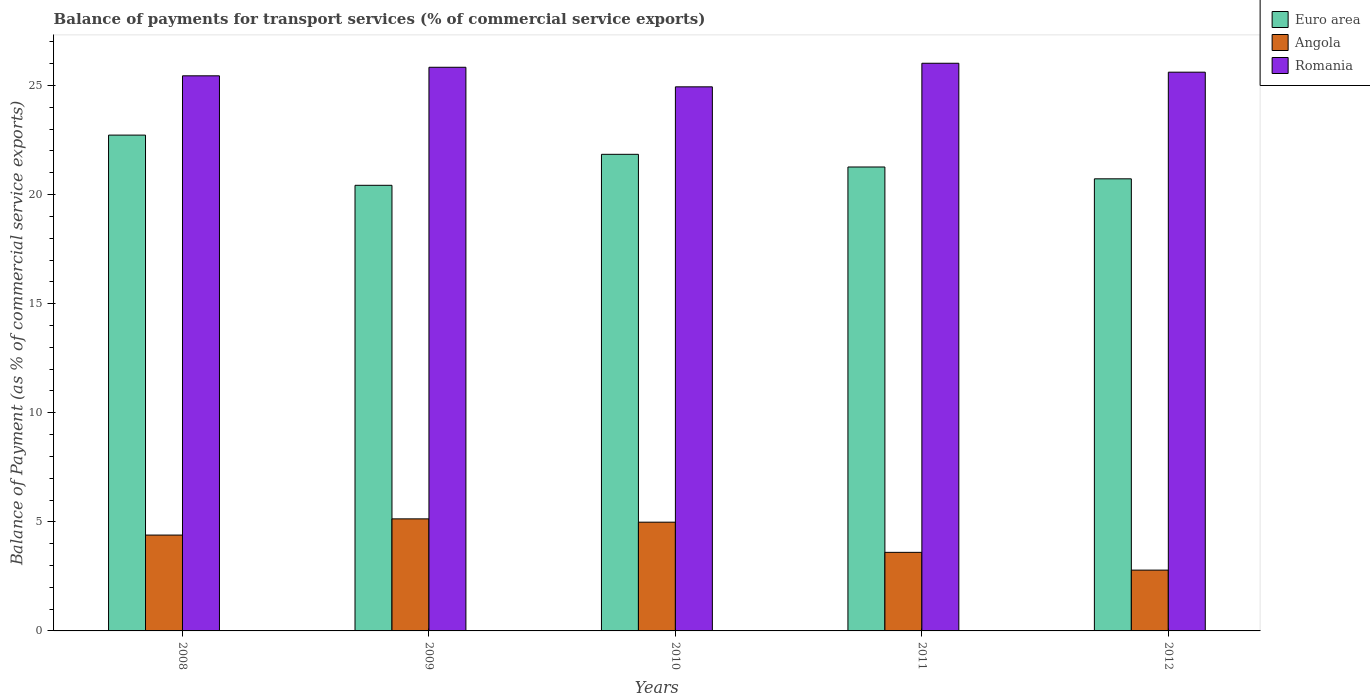Are the number of bars per tick equal to the number of legend labels?
Your answer should be very brief. Yes. Are the number of bars on each tick of the X-axis equal?
Provide a short and direct response. Yes. How many bars are there on the 3rd tick from the left?
Provide a succinct answer. 3. How many bars are there on the 5th tick from the right?
Keep it short and to the point. 3. What is the label of the 1st group of bars from the left?
Provide a short and direct response. 2008. In how many cases, is the number of bars for a given year not equal to the number of legend labels?
Provide a short and direct response. 0. What is the balance of payments for transport services in Angola in 2010?
Your response must be concise. 4.98. Across all years, what is the maximum balance of payments for transport services in Euro area?
Your answer should be compact. 22.73. Across all years, what is the minimum balance of payments for transport services in Euro area?
Your response must be concise. 20.42. In which year was the balance of payments for transport services in Romania minimum?
Your answer should be very brief. 2010. What is the total balance of payments for transport services in Romania in the graph?
Your answer should be compact. 127.84. What is the difference between the balance of payments for transport services in Angola in 2008 and that in 2012?
Keep it short and to the point. 1.61. What is the difference between the balance of payments for transport services in Euro area in 2009 and the balance of payments for transport services in Angola in 2012?
Offer a very short reply. 17.64. What is the average balance of payments for transport services in Euro area per year?
Your answer should be compact. 21.4. In the year 2012, what is the difference between the balance of payments for transport services in Romania and balance of payments for transport services in Angola?
Give a very brief answer. 22.82. In how many years, is the balance of payments for transport services in Angola greater than 18 %?
Your answer should be very brief. 0. What is the ratio of the balance of payments for transport services in Romania in 2009 to that in 2011?
Provide a succinct answer. 0.99. Is the difference between the balance of payments for transport services in Romania in 2009 and 2012 greater than the difference between the balance of payments for transport services in Angola in 2009 and 2012?
Your answer should be compact. No. What is the difference between the highest and the second highest balance of payments for transport services in Angola?
Provide a short and direct response. 0.15. What is the difference between the highest and the lowest balance of payments for transport services in Romania?
Your answer should be compact. 1.08. In how many years, is the balance of payments for transport services in Angola greater than the average balance of payments for transport services in Angola taken over all years?
Offer a terse response. 3. Is the sum of the balance of payments for transport services in Angola in 2008 and 2012 greater than the maximum balance of payments for transport services in Romania across all years?
Make the answer very short. No. What does the 2nd bar from the left in 2012 represents?
Provide a short and direct response. Angola. What does the 1st bar from the right in 2010 represents?
Give a very brief answer. Romania. How many bars are there?
Give a very brief answer. 15. Are all the bars in the graph horizontal?
Offer a terse response. No. What is the difference between two consecutive major ticks on the Y-axis?
Your response must be concise. 5. Are the values on the major ticks of Y-axis written in scientific E-notation?
Ensure brevity in your answer.  No. Where does the legend appear in the graph?
Your answer should be compact. Top right. What is the title of the graph?
Ensure brevity in your answer.  Balance of payments for transport services (% of commercial service exports). What is the label or title of the X-axis?
Make the answer very short. Years. What is the label or title of the Y-axis?
Offer a very short reply. Balance of Payment (as % of commercial service exports). What is the Balance of Payment (as % of commercial service exports) of Euro area in 2008?
Offer a very short reply. 22.73. What is the Balance of Payment (as % of commercial service exports) in Angola in 2008?
Provide a short and direct response. 4.39. What is the Balance of Payment (as % of commercial service exports) of Romania in 2008?
Your answer should be very brief. 25.44. What is the Balance of Payment (as % of commercial service exports) of Euro area in 2009?
Keep it short and to the point. 20.42. What is the Balance of Payment (as % of commercial service exports) of Angola in 2009?
Make the answer very short. 5.14. What is the Balance of Payment (as % of commercial service exports) in Romania in 2009?
Provide a short and direct response. 25.83. What is the Balance of Payment (as % of commercial service exports) of Euro area in 2010?
Give a very brief answer. 21.84. What is the Balance of Payment (as % of commercial service exports) of Angola in 2010?
Keep it short and to the point. 4.98. What is the Balance of Payment (as % of commercial service exports) of Romania in 2010?
Your response must be concise. 24.94. What is the Balance of Payment (as % of commercial service exports) of Euro area in 2011?
Provide a short and direct response. 21.26. What is the Balance of Payment (as % of commercial service exports) in Angola in 2011?
Offer a terse response. 3.6. What is the Balance of Payment (as % of commercial service exports) in Romania in 2011?
Give a very brief answer. 26.02. What is the Balance of Payment (as % of commercial service exports) in Euro area in 2012?
Make the answer very short. 20.72. What is the Balance of Payment (as % of commercial service exports) in Angola in 2012?
Your answer should be very brief. 2.79. What is the Balance of Payment (as % of commercial service exports) in Romania in 2012?
Keep it short and to the point. 25.61. Across all years, what is the maximum Balance of Payment (as % of commercial service exports) of Euro area?
Your response must be concise. 22.73. Across all years, what is the maximum Balance of Payment (as % of commercial service exports) of Angola?
Provide a succinct answer. 5.14. Across all years, what is the maximum Balance of Payment (as % of commercial service exports) of Romania?
Provide a short and direct response. 26.02. Across all years, what is the minimum Balance of Payment (as % of commercial service exports) in Euro area?
Keep it short and to the point. 20.42. Across all years, what is the minimum Balance of Payment (as % of commercial service exports) of Angola?
Offer a terse response. 2.79. Across all years, what is the minimum Balance of Payment (as % of commercial service exports) of Romania?
Ensure brevity in your answer.  24.94. What is the total Balance of Payment (as % of commercial service exports) in Euro area in the graph?
Provide a short and direct response. 106.98. What is the total Balance of Payment (as % of commercial service exports) in Angola in the graph?
Offer a terse response. 20.9. What is the total Balance of Payment (as % of commercial service exports) of Romania in the graph?
Offer a terse response. 127.84. What is the difference between the Balance of Payment (as % of commercial service exports) in Euro area in 2008 and that in 2009?
Ensure brevity in your answer.  2.3. What is the difference between the Balance of Payment (as % of commercial service exports) in Angola in 2008 and that in 2009?
Offer a terse response. -0.74. What is the difference between the Balance of Payment (as % of commercial service exports) in Romania in 2008 and that in 2009?
Provide a succinct answer. -0.39. What is the difference between the Balance of Payment (as % of commercial service exports) of Euro area in 2008 and that in 2010?
Provide a succinct answer. 0.88. What is the difference between the Balance of Payment (as % of commercial service exports) of Angola in 2008 and that in 2010?
Provide a short and direct response. -0.59. What is the difference between the Balance of Payment (as % of commercial service exports) of Romania in 2008 and that in 2010?
Keep it short and to the point. 0.51. What is the difference between the Balance of Payment (as % of commercial service exports) in Euro area in 2008 and that in 2011?
Make the answer very short. 1.46. What is the difference between the Balance of Payment (as % of commercial service exports) of Angola in 2008 and that in 2011?
Provide a short and direct response. 0.79. What is the difference between the Balance of Payment (as % of commercial service exports) of Romania in 2008 and that in 2011?
Offer a terse response. -0.58. What is the difference between the Balance of Payment (as % of commercial service exports) in Euro area in 2008 and that in 2012?
Give a very brief answer. 2. What is the difference between the Balance of Payment (as % of commercial service exports) of Angola in 2008 and that in 2012?
Make the answer very short. 1.61. What is the difference between the Balance of Payment (as % of commercial service exports) in Romania in 2008 and that in 2012?
Your answer should be very brief. -0.17. What is the difference between the Balance of Payment (as % of commercial service exports) of Euro area in 2009 and that in 2010?
Make the answer very short. -1.42. What is the difference between the Balance of Payment (as % of commercial service exports) of Angola in 2009 and that in 2010?
Provide a short and direct response. 0.15. What is the difference between the Balance of Payment (as % of commercial service exports) of Romania in 2009 and that in 2010?
Your response must be concise. 0.9. What is the difference between the Balance of Payment (as % of commercial service exports) of Euro area in 2009 and that in 2011?
Provide a short and direct response. -0.84. What is the difference between the Balance of Payment (as % of commercial service exports) of Angola in 2009 and that in 2011?
Offer a terse response. 1.53. What is the difference between the Balance of Payment (as % of commercial service exports) in Romania in 2009 and that in 2011?
Your response must be concise. -0.18. What is the difference between the Balance of Payment (as % of commercial service exports) in Euro area in 2009 and that in 2012?
Provide a succinct answer. -0.3. What is the difference between the Balance of Payment (as % of commercial service exports) in Angola in 2009 and that in 2012?
Make the answer very short. 2.35. What is the difference between the Balance of Payment (as % of commercial service exports) in Romania in 2009 and that in 2012?
Offer a very short reply. 0.22. What is the difference between the Balance of Payment (as % of commercial service exports) of Euro area in 2010 and that in 2011?
Offer a very short reply. 0.58. What is the difference between the Balance of Payment (as % of commercial service exports) in Angola in 2010 and that in 2011?
Give a very brief answer. 1.38. What is the difference between the Balance of Payment (as % of commercial service exports) of Romania in 2010 and that in 2011?
Provide a succinct answer. -1.08. What is the difference between the Balance of Payment (as % of commercial service exports) of Euro area in 2010 and that in 2012?
Provide a succinct answer. 1.12. What is the difference between the Balance of Payment (as % of commercial service exports) of Angola in 2010 and that in 2012?
Provide a succinct answer. 2.2. What is the difference between the Balance of Payment (as % of commercial service exports) of Romania in 2010 and that in 2012?
Provide a short and direct response. -0.67. What is the difference between the Balance of Payment (as % of commercial service exports) in Euro area in 2011 and that in 2012?
Your response must be concise. 0.54. What is the difference between the Balance of Payment (as % of commercial service exports) in Angola in 2011 and that in 2012?
Give a very brief answer. 0.81. What is the difference between the Balance of Payment (as % of commercial service exports) in Romania in 2011 and that in 2012?
Your answer should be compact. 0.41. What is the difference between the Balance of Payment (as % of commercial service exports) in Euro area in 2008 and the Balance of Payment (as % of commercial service exports) in Angola in 2009?
Keep it short and to the point. 17.59. What is the difference between the Balance of Payment (as % of commercial service exports) of Euro area in 2008 and the Balance of Payment (as % of commercial service exports) of Romania in 2009?
Make the answer very short. -3.11. What is the difference between the Balance of Payment (as % of commercial service exports) in Angola in 2008 and the Balance of Payment (as % of commercial service exports) in Romania in 2009?
Give a very brief answer. -21.44. What is the difference between the Balance of Payment (as % of commercial service exports) in Euro area in 2008 and the Balance of Payment (as % of commercial service exports) in Angola in 2010?
Provide a short and direct response. 17.74. What is the difference between the Balance of Payment (as % of commercial service exports) of Euro area in 2008 and the Balance of Payment (as % of commercial service exports) of Romania in 2010?
Ensure brevity in your answer.  -2.21. What is the difference between the Balance of Payment (as % of commercial service exports) of Angola in 2008 and the Balance of Payment (as % of commercial service exports) of Romania in 2010?
Keep it short and to the point. -20.54. What is the difference between the Balance of Payment (as % of commercial service exports) in Euro area in 2008 and the Balance of Payment (as % of commercial service exports) in Angola in 2011?
Keep it short and to the point. 19.12. What is the difference between the Balance of Payment (as % of commercial service exports) of Euro area in 2008 and the Balance of Payment (as % of commercial service exports) of Romania in 2011?
Your answer should be very brief. -3.29. What is the difference between the Balance of Payment (as % of commercial service exports) in Angola in 2008 and the Balance of Payment (as % of commercial service exports) in Romania in 2011?
Your response must be concise. -21.62. What is the difference between the Balance of Payment (as % of commercial service exports) of Euro area in 2008 and the Balance of Payment (as % of commercial service exports) of Angola in 2012?
Ensure brevity in your answer.  19.94. What is the difference between the Balance of Payment (as % of commercial service exports) of Euro area in 2008 and the Balance of Payment (as % of commercial service exports) of Romania in 2012?
Your answer should be compact. -2.88. What is the difference between the Balance of Payment (as % of commercial service exports) in Angola in 2008 and the Balance of Payment (as % of commercial service exports) in Romania in 2012?
Keep it short and to the point. -21.22. What is the difference between the Balance of Payment (as % of commercial service exports) in Euro area in 2009 and the Balance of Payment (as % of commercial service exports) in Angola in 2010?
Provide a short and direct response. 15.44. What is the difference between the Balance of Payment (as % of commercial service exports) in Euro area in 2009 and the Balance of Payment (as % of commercial service exports) in Romania in 2010?
Keep it short and to the point. -4.51. What is the difference between the Balance of Payment (as % of commercial service exports) of Angola in 2009 and the Balance of Payment (as % of commercial service exports) of Romania in 2010?
Your response must be concise. -19.8. What is the difference between the Balance of Payment (as % of commercial service exports) in Euro area in 2009 and the Balance of Payment (as % of commercial service exports) in Angola in 2011?
Provide a succinct answer. 16.82. What is the difference between the Balance of Payment (as % of commercial service exports) in Euro area in 2009 and the Balance of Payment (as % of commercial service exports) in Romania in 2011?
Give a very brief answer. -5.59. What is the difference between the Balance of Payment (as % of commercial service exports) in Angola in 2009 and the Balance of Payment (as % of commercial service exports) in Romania in 2011?
Keep it short and to the point. -20.88. What is the difference between the Balance of Payment (as % of commercial service exports) of Euro area in 2009 and the Balance of Payment (as % of commercial service exports) of Angola in 2012?
Offer a terse response. 17.64. What is the difference between the Balance of Payment (as % of commercial service exports) in Euro area in 2009 and the Balance of Payment (as % of commercial service exports) in Romania in 2012?
Provide a succinct answer. -5.19. What is the difference between the Balance of Payment (as % of commercial service exports) in Angola in 2009 and the Balance of Payment (as % of commercial service exports) in Romania in 2012?
Offer a very short reply. -20.47. What is the difference between the Balance of Payment (as % of commercial service exports) in Euro area in 2010 and the Balance of Payment (as % of commercial service exports) in Angola in 2011?
Provide a succinct answer. 18.24. What is the difference between the Balance of Payment (as % of commercial service exports) in Euro area in 2010 and the Balance of Payment (as % of commercial service exports) in Romania in 2011?
Ensure brevity in your answer.  -4.17. What is the difference between the Balance of Payment (as % of commercial service exports) of Angola in 2010 and the Balance of Payment (as % of commercial service exports) of Romania in 2011?
Give a very brief answer. -21.03. What is the difference between the Balance of Payment (as % of commercial service exports) of Euro area in 2010 and the Balance of Payment (as % of commercial service exports) of Angola in 2012?
Ensure brevity in your answer.  19.06. What is the difference between the Balance of Payment (as % of commercial service exports) in Euro area in 2010 and the Balance of Payment (as % of commercial service exports) in Romania in 2012?
Ensure brevity in your answer.  -3.77. What is the difference between the Balance of Payment (as % of commercial service exports) of Angola in 2010 and the Balance of Payment (as % of commercial service exports) of Romania in 2012?
Give a very brief answer. -20.63. What is the difference between the Balance of Payment (as % of commercial service exports) in Euro area in 2011 and the Balance of Payment (as % of commercial service exports) in Angola in 2012?
Make the answer very short. 18.48. What is the difference between the Balance of Payment (as % of commercial service exports) of Euro area in 2011 and the Balance of Payment (as % of commercial service exports) of Romania in 2012?
Offer a very short reply. -4.35. What is the difference between the Balance of Payment (as % of commercial service exports) of Angola in 2011 and the Balance of Payment (as % of commercial service exports) of Romania in 2012?
Offer a terse response. -22.01. What is the average Balance of Payment (as % of commercial service exports) of Euro area per year?
Make the answer very short. 21.4. What is the average Balance of Payment (as % of commercial service exports) in Angola per year?
Ensure brevity in your answer.  4.18. What is the average Balance of Payment (as % of commercial service exports) of Romania per year?
Your response must be concise. 25.57. In the year 2008, what is the difference between the Balance of Payment (as % of commercial service exports) of Euro area and Balance of Payment (as % of commercial service exports) of Angola?
Keep it short and to the point. 18.33. In the year 2008, what is the difference between the Balance of Payment (as % of commercial service exports) of Euro area and Balance of Payment (as % of commercial service exports) of Romania?
Give a very brief answer. -2.72. In the year 2008, what is the difference between the Balance of Payment (as % of commercial service exports) in Angola and Balance of Payment (as % of commercial service exports) in Romania?
Your answer should be very brief. -21.05. In the year 2009, what is the difference between the Balance of Payment (as % of commercial service exports) in Euro area and Balance of Payment (as % of commercial service exports) in Angola?
Offer a very short reply. 15.29. In the year 2009, what is the difference between the Balance of Payment (as % of commercial service exports) of Euro area and Balance of Payment (as % of commercial service exports) of Romania?
Provide a short and direct response. -5.41. In the year 2009, what is the difference between the Balance of Payment (as % of commercial service exports) of Angola and Balance of Payment (as % of commercial service exports) of Romania?
Your answer should be compact. -20.7. In the year 2010, what is the difference between the Balance of Payment (as % of commercial service exports) in Euro area and Balance of Payment (as % of commercial service exports) in Angola?
Offer a very short reply. 16.86. In the year 2010, what is the difference between the Balance of Payment (as % of commercial service exports) of Euro area and Balance of Payment (as % of commercial service exports) of Romania?
Your response must be concise. -3.09. In the year 2010, what is the difference between the Balance of Payment (as % of commercial service exports) of Angola and Balance of Payment (as % of commercial service exports) of Romania?
Your answer should be compact. -19.95. In the year 2011, what is the difference between the Balance of Payment (as % of commercial service exports) in Euro area and Balance of Payment (as % of commercial service exports) in Angola?
Provide a succinct answer. 17.66. In the year 2011, what is the difference between the Balance of Payment (as % of commercial service exports) of Euro area and Balance of Payment (as % of commercial service exports) of Romania?
Keep it short and to the point. -4.75. In the year 2011, what is the difference between the Balance of Payment (as % of commercial service exports) in Angola and Balance of Payment (as % of commercial service exports) in Romania?
Ensure brevity in your answer.  -22.42. In the year 2012, what is the difference between the Balance of Payment (as % of commercial service exports) of Euro area and Balance of Payment (as % of commercial service exports) of Angola?
Keep it short and to the point. 17.93. In the year 2012, what is the difference between the Balance of Payment (as % of commercial service exports) of Euro area and Balance of Payment (as % of commercial service exports) of Romania?
Make the answer very short. -4.89. In the year 2012, what is the difference between the Balance of Payment (as % of commercial service exports) of Angola and Balance of Payment (as % of commercial service exports) of Romania?
Provide a succinct answer. -22.82. What is the ratio of the Balance of Payment (as % of commercial service exports) of Euro area in 2008 to that in 2009?
Offer a very short reply. 1.11. What is the ratio of the Balance of Payment (as % of commercial service exports) in Angola in 2008 to that in 2009?
Your response must be concise. 0.86. What is the ratio of the Balance of Payment (as % of commercial service exports) of Romania in 2008 to that in 2009?
Offer a very short reply. 0.98. What is the ratio of the Balance of Payment (as % of commercial service exports) in Euro area in 2008 to that in 2010?
Offer a very short reply. 1.04. What is the ratio of the Balance of Payment (as % of commercial service exports) in Angola in 2008 to that in 2010?
Provide a succinct answer. 0.88. What is the ratio of the Balance of Payment (as % of commercial service exports) in Romania in 2008 to that in 2010?
Provide a short and direct response. 1.02. What is the ratio of the Balance of Payment (as % of commercial service exports) of Euro area in 2008 to that in 2011?
Make the answer very short. 1.07. What is the ratio of the Balance of Payment (as % of commercial service exports) of Angola in 2008 to that in 2011?
Offer a terse response. 1.22. What is the ratio of the Balance of Payment (as % of commercial service exports) of Romania in 2008 to that in 2011?
Provide a succinct answer. 0.98. What is the ratio of the Balance of Payment (as % of commercial service exports) in Euro area in 2008 to that in 2012?
Ensure brevity in your answer.  1.1. What is the ratio of the Balance of Payment (as % of commercial service exports) in Angola in 2008 to that in 2012?
Your answer should be very brief. 1.58. What is the ratio of the Balance of Payment (as % of commercial service exports) in Romania in 2008 to that in 2012?
Your response must be concise. 0.99. What is the ratio of the Balance of Payment (as % of commercial service exports) of Euro area in 2009 to that in 2010?
Offer a terse response. 0.94. What is the ratio of the Balance of Payment (as % of commercial service exports) in Angola in 2009 to that in 2010?
Provide a succinct answer. 1.03. What is the ratio of the Balance of Payment (as % of commercial service exports) in Romania in 2009 to that in 2010?
Keep it short and to the point. 1.04. What is the ratio of the Balance of Payment (as % of commercial service exports) in Euro area in 2009 to that in 2011?
Offer a very short reply. 0.96. What is the ratio of the Balance of Payment (as % of commercial service exports) in Angola in 2009 to that in 2011?
Your answer should be compact. 1.43. What is the ratio of the Balance of Payment (as % of commercial service exports) in Romania in 2009 to that in 2011?
Make the answer very short. 0.99. What is the ratio of the Balance of Payment (as % of commercial service exports) in Euro area in 2009 to that in 2012?
Your answer should be compact. 0.99. What is the ratio of the Balance of Payment (as % of commercial service exports) in Angola in 2009 to that in 2012?
Provide a short and direct response. 1.84. What is the ratio of the Balance of Payment (as % of commercial service exports) of Romania in 2009 to that in 2012?
Offer a very short reply. 1.01. What is the ratio of the Balance of Payment (as % of commercial service exports) in Euro area in 2010 to that in 2011?
Your answer should be compact. 1.03. What is the ratio of the Balance of Payment (as % of commercial service exports) of Angola in 2010 to that in 2011?
Keep it short and to the point. 1.38. What is the ratio of the Balance of Payment (as % of commercial service exports) of Romania in 2010 to that in 2011?
Your answer should be very brief. 0.96. What is the ratio of the Balance of Payment (as % of commercial service exports) of Euro area in 2010 to that in 2012?
Provide a short and direct response. 1.05. What is the ratio of the Balance of Payment (as % of commercial service exports) in Angola in 2010 to that in 2012?
Keep it short and to the point. 1.79. What is the ratio of the Balance of Payment (as % of commercial service exports) of Romania in 2010 to that in 2012?
Your answer should be compact. 0.97. What is the ratio of the Balance of Payment (as % of commercial service exports) of Euro area in 2011 to that in 2012?
Provide a succinct answer. 1.03. What is the ratio of the Balance of Payment (as % of commercial service exports) of Angola in 2011 to that in 2012?
Offer a terse response. 1.29. What is the difference between the highest and the second highest Balance of Payment (as % of commercial service exports) in Euro area?
Give a very brief answer. 0.88. What is the difference between the highest and the second highest Balance of Payment (as % of commercial service exports) in Angola?
Give a very brief answer. 0.15. What is the difference between the highest and the second highest Balance of Payment (as % of commercial service exports) of Romania?
Offer a very short reply. 0.18. What is the difference between the highest and the lowest Balance of Payment (as % of commercial service exports) of Euro area?
Your answer should be very brief. 2.3. What is the difference between the highest and the lowest Balance of Payment (as % of commercial service exports) in Angola?
Offer a very short reply. 2.35. What is the difference between the highest and the lowest Balance of Payment (as % of commercial service exports) of Romania?
Make the answer very short. 1.08. 